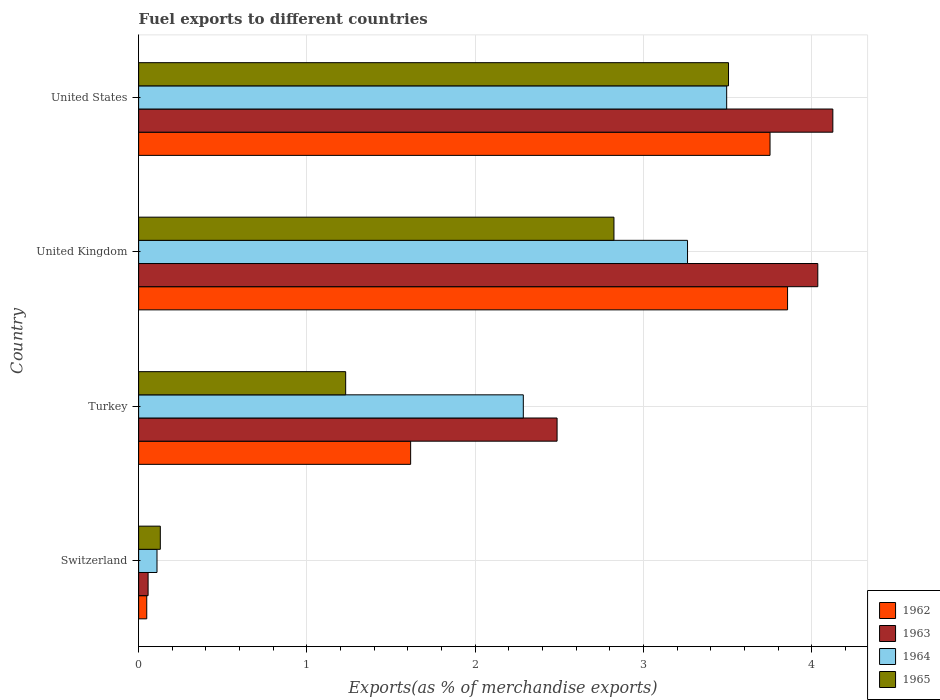How many groups of bars are there?
Your answer should be very brief. 4. What is the label of the 4th group of bars from the top?
Give a very brief answer. Switzerland. In how many cases, is the number of bars for a given country not equal to the number of legend labels?
Provide a short and direct response. 0. What is the percentage of exports to different countries in 1965 in Turkey?
Your answer should be compact. 1.23. Across all countries, what is the maximum percentage of exports to different countries in 1964?
Your answer should be very brief. 3.49. Across all countries, what is the minimum percentage of exports to different countries in 1963?
Your answer should be very brief. 0.06. In which country was the percentage of exports to different countries in 1964 maximum?
Make the answer very short. United States. In which country was the percentage of exports to different countries in 1963 minimum?
Your answer should be compact. Switzerland. What is the total percentage of exports to different countries in 1964 in the graph?
Provide a short and direct response. 9.15. What is the difference between the percentage of exports to different countries in 1962 in Switzerland and that in United States?
Provide a short and direct response. -3.7. What is the difference between the percentage of exports to different countries in 1962 in Switzerland and the percentage of exports to different countries in 1963 in Turkey?
Offer a terse response. -2.44. What is the average percentage of exports to different countries in 1965 per country?
Make the answer very short. 1.92. What is the difference between the percentage of exports to different countries in 1963 and percentage of exports to different countries in 1965 in United States?
Give a very brief answer. 0.62. What is the ratio of the percentage of exports to different countries in 1963 in United Kingdom to that in United States?
Give a very brief answer. 0.98. What is the difference between the highest and the second highest percentage of exports to different countries in 1964?
Provide a succinct answer. 0.23. What is the difference between the highest and the lowest percentage of exports to different countries in 1963?
Offer a very short reply. 4.07. In how many countries, is the percentage of exports to different countries in 1964 greater than the average percentage of exports to different countries in 1964 taken over all countries?
Ensure brevity in your answer.  2. What does the 3rd bar from the bottom in United Kingdom represents?
Ensure brevity in your answer.  1964. Is it the case that in every country, the sum of the percentage of exports to different countries in 1962 and percentage of exports to different countries in 1964 is greater than the percentage of exports to different countries in 1963?
Your response must be concise. Yes. Are all the bars in the graph horizontal?
Keep it short and to the point. Yes. How many countries are there in the graph?
Your answer should be compact. 4. What is the difference between two consecutive major ticks on the X-axis?
Offer a very short reply. 1. Are the values on the major ticks of X-axis written in scientific E-notation?
Give a very brief answer. No. Does the graph contain grids?
Keep it short and to the point. Yes. What is the title of the graph?
Provide a succinct answer. Fuel exports to different countries. Does "2010" appear as one of the legend labels in the graph?
Keep it short and to the point. No. What is the label or title of the X-axis?
Offer a terse response. Exports(as % of merchandise exports). What is the label or title of the Y-axis?
Your response must be concise. Country. What is the Exports(as % of merchandise exports) of 1962 in Switzerland?
Offer a very short reply. 0.05. What is the Exports(as % of merchandise exports) in 1963 in Switzerland?
Ensure brevity in your answer.  0.06. What is the Exports(as % of merchandise exports) of 1964 in Switzerland?
Offer a very short reply. 0.11. What is the Exports(as % of merchandise exports) of 1965 in Switzerland?
Your response must be concise. 0.13. What is the Exports(as % of merchandise exports) in 1962 in Turkey?
Give a very brief answer. 1.62. What is the Exports(as % of merchandise exports) of 1963 in Turkey?
Give a very brief answer. 2.49. What is the Exports(as % of merchandise exports) in 1964 in Turkey?
Ensure brevity in your answer.  2.29. What is the Exports(as % of merchandise exports) of 1965 in Turkey?
Give a very brief answer. 1.23. What is the Exports(as % of merchandise exports) of 1962 in United Kingdom?
Offer a terse response. 3.86. What is the Exports(as % of merchandise exports) in 1963 in United Kingdom?
Offer a terse response. 4.04. What is the Exports(as % of merchandise exports) of 1964 in United Kingdom?
Provide a succinct answer. 3.26. What is the Exports(as % of merchandise exports) in 1965 in United Kingdom?
Your answer should be compact. 2.82. What is the Exports(as % of merchandise exports) of 1962 in United States?
Make the answer very short. 3.75. What is the Exports(as % of merchandise exports) of 1963 in United States?
Provide a succinct answer. 4.13. What is the Exports(as % of merchandise exports) in 1964 in United States?
Provide a succinct answer. 3.49. What is the Exports(as % of merchandise exports) of 1965 in United States?
Offer a very short reply. 3.51. Across all countries, what is the maximum Exports(as % of merchandise exports) in 1962?
Your answer should be very brief. 3.86. Across all countries, what is the maximum Exports(as % of merchandise exports) in 1963?
Ensure brevity in your answer.  4.13. Across all countries, what is the maximum Exports(as % of merchandise exports) in 1964?
Provide a succinct answer. 3.49. Across all countries, what is the maximum Exports(as % of merchandise exports) of 1965?
Your answer should be compact. 3.51. Across all countries, what is the minimum Exports(as % of merchandise exports) of 1962?
Offer a very short reply. 0.05. Across all countries, what is the minimum Exports(as % of merchandise exports) of 1963?
Make the answer very short. 0.06. Across all countries, what is the minimum Exports(as % of merchandise exports) of 1964?
Your response must be concise. 0.11. Across all countries, what is the minimum Exports(as % of merchandise exports) of 1965?
Offer a very short reply. 0.13. What is the total Exports(as % of merchandise exports) in 1962 in the graph?
Offer a very short reply. 9.27. What is the total Exports(as % of merchandise exports) in 1963 in the graph?
Give a very brief answer. 10.7. What is the total Exports(as % of merchandise exports) of 1964 in the graph?
Provide a succinct answer. 9.15. What is the total Exports(as % of merchandise exports) of 1965 in the graph?
Provide a short and direct response. 7.69. What is the difference between the Exports(as % of merchandise exports) of 1962 in Switzerland and that in Turkey?
Your answer should be very brief. -1.57. What is the difference between the Exports(as % of merchandise exports) in 1963 in Switzerland and that in Turkey?
Your answer should be very brief. -2.43. What is the difference between the Exports(as % of merchandise exports) in 1964 in Switzerland and that in Turkey?
Keep it short and to the point. -2.18. What is the difference between the Exports(as % of merchandise exports) in 1965 in Switzerland and that in Turkey?
Give a very brief answer. -1.1. What is the difference between the Exports(as % of merchandise exports) of 1962 in Switzerland and that in United Kingdom?
Your answer should be compact. -3.81. What is the difference between the Exports(as % of merchandise exports) in 1963 in Switzerland and that in United Kingdom?
Your response must be concise. -3.98. What is the difference between the Exports(as % of merchandise exports) in 1964 in Switzerland and that in United Kingdom?
Make the answer very short. -3.15. What is the difference between the Exports(as % of merchandise exports) of 1965 in Switzerland and that in United Kingdom?
Offer a very short reply. -2.7. What is the difference between the Exports(as % of merchandise exports) of 1962 in Switzerland and that in United States?
Provide a succinct answer. -3.7. What is the difference between the Exports(as % of merchandise exports) in 1963 in Switzerland and that in United States?
Offer a very short reply. -4.07. What is the difference between the Exports(as % of merchandise exports) of 1964 in Switzerland and that in United States?
Provide a succinct answer. -3.39. What is the difference between the Exports(as % of merchandise exports) of 1965 in Switzerland and that in United States?
Make the answer very short. -3.38. What is the difference between the Exports(as % of merchandise exports) of 1962 in Turkey and that in United Kingdom?
Make the answer very short. -2.24. What is the difference between the Exports(as % of merchandise exports) of 1963 in Turkey and that in United Kingdom?
Provide a short and direct response. -1.55. What is the difference between the Exports(as % of merchandise exports) of 1964 in Turkey and that in United Kingdom?
Offer a terse response. -0.98. What is the difference between the Exports(as % of merchandise exports) of 1965 in Turkey and that in United Kingdom?
Offer a terse response. -1.59. What is the difference between the Exports(as % of merchandise exports) in 1962 in Turkey and that in United States?
Offer a terse response. -2.14. What is the difference between the Exports(as % of merchandise exports) of 1963 in Turkey and that in United States?
Your response must be concise. -1.64. What is the difference between the Exports(as % of merchandise exports) of 1964 in Turkey and that in United States?
Offer a very short reply. -1.21. What is the difference between the Exports(as % of merchandise exports) of 1965 in Turkey and that in United States?
Keep it short and to the point. -2.27. What is the difference between the Exports(as % of merchandise exports) in 1962 in United Kingdom and that in United States?
Your answer should be very brief. 0.1. What is the difference between the Exports(as % of merchandise exports) of 1963 in United Kingdom and that in United States?
Make the answer very short. -0.09. What is the difference between the Exports(as % of merchandise exports) in 1964 in United Kingdom and that in United States?
Make the answer very short. -0.23. What is the difference between the Exports(as % of merchandise exports) of 1965 in United Kingdom and that in United States?
Ensure brevity in your answer.  -0.68. What is the difference between the Exports(as % of merchandise exports) of 1962 in Switzerland and the Exports(as % of merchandise exports) of 1963 in Turkey?
Your answer should be very brief. -2.44. What is the difference between the Exports(as % of merchandise exports) of 1962 in Switzerland and the Exports(as % of merchandise exports) of 1964 in Turkey?
Your response must be concise. -2.24. What is the difference between the Exports(as % of merchandise exports) of 1962 in Switzerland and the Exports(as % of merchandise exports) of 1965 in Turkey?
Give a very brief answer. -1.18. What is the difference between the Exports(as % of merchandise exports) of 1963 in Switzerland and the Exports(as % of merchandise exports) of 1964 in Turkey?
Offer a terse response. -2.23. What is the difference between the Exports(as % of merchandise exports) of 1963 in Switzerland and the Exports(as % of merchandise exports) of 1965 in Turkey?
Provide a succinct answer. -1.17. What is the difference between the Exports(as % of merchandise exports) in 1964 in Switzerland and the Exports(as % of merchandise exports) in 1965 in Turkey?
Ensure brevity in your answer.  -1.12. What is the difference between the Exports(as % of merchandise exports) in 1962 in Switzerland and the Exports(as % of merchandise exports) in 1963 in United Kingdom?
Your response must be concise. -3.99. What is the difference between the Exports(as % of merchandise exports) of 1962 in Switzerland and the Exports(as % of merchandise exports) of 1964 in United Kingdom?
Make the answer very short. -3.21. What is the difference between the Exports(as % of merchandise exports) in 1962 in Switzerland and the Exports(as % of merchandise exports) in 1965 in United Kingdom?
Offer a very short reply. -2.78. What is the difference between the Exports(as % of merchandise exports) of 1963 in Switzerland and the Exports(as % of merchandise exports) of 1964 in United Kingdom?
Offer a very short reply. -3.21. What is the difference between the Exports(as % of merchandise exports) of 1963 in Switzerland and the Exports(as % of merchandise exports) of 1965 in United Kingdom?
Provide a succinct answer. -2.77. What is the difference between the Exports(as % of merchandise exports) of 1964 in Switzerland and the Exports(as % of merchandise exports) of 1965 in United Kingdom?
Provide a succinct answer. -2.72. What is the difference between the Exports(as % of merchandise exports) of 1962 in Switzerland and the Exports(as % of merchandise exports) of 1963 in United States?
Provide a succinct answer. -4.08. What is the difference between the Exports(as % of merchandise exports) of 1962 in Switzerland and the Exports(as % of merchandise exports) of 1964 in United States?
Offer a very short reply. -3.45. What is the difference between the Exports(as % of merchandise exports) of 1962 in Switzerland and the Exports(as % of merchandise exports) of 1965 in United States?
Make the answer very short. -3.46. What is the difference between the Exports(as % of merchandise exports) of 1963 in Switzerland and the Exports(as % of merchandise exports) of 1964 in United States?
Provide a succinct answer. -3.44. What is the difference between the Exports(as % of merchandise exports) in 1963 in Switzerland and the Exports(as % of merchandise exports) in 1965 in United States?
Provide a short and direct response. -3.45. What is the difference between the Exports(as % of merchandise exports) of 1964 in Switzerland and the Exports(as % of merchandise exports) of 1965 in United States?
Your answer should be very brief. -3.4. What is the difference between the Exports(as % of merchandise exports) of 1962 in Turkey and the Exports(as % of merchandise exports) of 1963 in United Kingdom?
Ensure brevity in your answer.  -2.42. What is the difference between the Exports(as % of merchandise exports) in 1962 in Turkey and the Exports(as % of merchandise exports) in 1964 in United Kingdom?
Make the answer very short. -1.65. What is the difference between the Exports(as % of merchandise exports) in 1962 in Turkey and the Exports(as % of merchandise exports) in 1965 in United Kingdom?
Ensure brevity in your answer.  -1.21. What is the difference between the Exports(as % of merchandise exports) in 1963 in Turkey and the Exports(as % of merchandise exports) in 1964 in United Kingdom?
Ensure brevity in your answer.  -0.78. What is the difference between the Exports(as % of merchandise exports) in 1963 in Turkey and the Exports(as % of merchandise exports) in 1965 in United Kingdom?
Keep it short and to the point. -0.34. What is the difference between the Exports(as % of merchandise exports) of 1964 in Turkey and the Exports(as % of merchandise exports) of 1965 in United Kingdom?
Offer a very short reply. -0.54. What is the difference between the Exports(as % of merchandise exports) in 1962 in Turkey and the Exports(as % of merchandise exports) in 1963 in United States?
Keep it short and to the point. -2.51. What is the difference between the Exports(as % of merchandise exports) in 1962 in Turkey and the Exports(as % of merchandise exports) in 1964 in United States?
Provide a short and direct response. -1.88. What is the difference between the Exports(as % of merchandise exports) in 1962 in Turkey and the Exports(as % of merchandise exports) in 1965 in United States?
Make the answer very short. -1.89. What is the difference between the Exports(as % of merchandise exports) in 1963 in Turkey and the Exports(as % of merchandise exports) in 1964 in United States?
Your response must be concise. -1.01. What is the difference between the Exports(as % of merchandise exports) of 1963 in Turkey and the Exports(as % of merchandise exports) of 1965 in United States?
Offer a terse response. -1.02. What is the difference between the Exports(as % of merchandise exports) of 1964 in Turkey and the Exports(as % of merchandise exports) of 1965 in United States?
Provide a short and direct response. -1.22. What is the difference between the Exports(as % of merchandise exports) in 1962 in United Kingdom and the Exports(as % of merchandise exports) in 1963 in United States?
Offer a terse response. -0.27. What is the difference between the Exports(as % of merchandise exports) of 1962 in United Kingdom and the Exports(as % of merchandise exports) of 1964 in United States?
Give a very brief answer. 0.36. What is the difference between the Exports(as % of merchandise exports) of 1962 in United Kingdom and the Exports(as % of merchandise exports) of 1965 in United States?
Give a very brief answer. 0.35. What is the difference between the Exports(as % of merchandise exports) in 1963 in United Kingdom and the Exports(as % of merchandise exports) in 1964 in United States?
Provide a short and direct response. 0.54. What is the difference between the Exports(as % of merchandise exports) in 1963 in United Kingdom and the Exports(as % of merchandise exports) in 1965 in United States?
Ensure brevity in your answer.  0.53. What is the difference between the Exports(as % of merchandise exports) of 1964 in United Kingdom and the Exports(as % of merchandise exports) of 1965 in United States?
Keep it short and to the point. -0.24. What is the average Exports(as % of merchandise exports) in 1962 per country?
Your answer should be compact. 2.32. What is the average Exports(as % of merchandise exports) in 1963 per country?
Provide a succinct answer. 2.68. What is the average Exports(as % of merchandise exports) of 1964 per country?
Keep it short and to the point. 2.29. What is the average Exports(as % of merchandise exports) of 1965 per country?
Give a very brief answer. 1.92. What is the difference between the Exports(as % of merchandise exports) in 1962 and Exports(as % of merchandise exports) in 1963 in Switzerland?
Keep it short and to the point. -0.01. What is the difference between the Exports(as % of merchandise exports) of 1962 and Exports(as % of merchandise exports) of 1964 in Switzerland?
Keep it short and to the point. -0.06. What is the difference between the Exports(as % of merchandise exports) in 1962 and Exports(as % of merchandise exports) in 1965 in Switzerland?
Ensure brevity in your answer.  -0.08. What is the difference between the Exports(as % of merchandise exports) in 1963 and Exports(as % of merchandise exports) in 1964 in Switzerland?
Provide a succinct answer. -0.05. What is the difference between the Exports(as % of merchandise exports) of 1963 and Exports(as % of merchandise exports) of 1965 in Switzerland?
Make the answer very short. -0.07. What is the difference between the Exports(as % of merchandise exports) in 1964 and Exports(as % of merchandise exports) in 1965 in Switzerland?
Offer a very short reply. -0.02. What is the difference between the Exports(as % of merchandise exports) of 1962 and Exports(as % of merchandise exports) of 1963 in Turkey?
Provide a short and direct response. -0.87. What is the difference between the Exports(as % of merchandise exports) of 1962 and Exports(as % of merchandise exports) of 1964 in Turkey?
Make the answer very short. -0.67. What is the difference between the Exports(as % of merchandise exports) in 1962 and Exports(as % of merchandise exports) in 1965 in Turkey?
Ensure brevity in your answer.  0.39. What is the difference between the Exports(as % of merchandise exports) in 1963 and Exports(as % of merchandise exports) in 1964 in Turkey?
Make the answer very short. 0.2. What is the difference between the Exports(as % of merchandise exports) in 1963 and Exports(as % of merchandise exports) in 1965 in Turkey?
Give a very brief answer. 1.26. What is the difference between the Exports(as % of merchandise exports) in 1964 and Exports(as % of merchandise exports) in 1965 in Turkey?
Keep it short and to the point. 1.06. What is the difference between the Exports(as % of merchandise exports) in 1962 and Exports(as % of merchandise exports) in 1963 in United Kingdom?
Give a very brief answer. -0.18. What is the difference between the Exports(as % of merchandise exports) in 1962 and Exports(as % of merchandise exports) in 1964 in United Kingdom?
Keep it short and to the point. 0.59. What is the difference between the Exports(as % of merchandise exports) of 1962 and Exports(as % of merchandise exports) of 1965 in United Kingdom?
Your answer should be compact. 1.03. What is the difference between the Exports(as % of merchandise exports) of 1963 and Exports(as % of merchandise exports) of 1964 in United Kingdom?
Provide a short and direct response. 0.77. What is the difference between the Exports(as % of merchandise exports) in 1963 and Exports(as % of merchandise exports) in 1965 in United Kingdom?
Offer a very short reply. 1.21. What is the difference between the Exports(as % of merchandise exports) of 1964 and Exports(as % of merchandise exports) of 1965 in United Kingdom?
Provide a short and direct response. 0.44. What is the difference between the Exports(as % of merchandise exports) of 1962 and Exports(as % of merchandise exports) of 1963 in United States?
Make the answer very short. -0.37. What is the difference between the Exports(as % of merchandise exports) in 1962 and Exports(as % of merchandise exports) in 1964 in United States?
Provide a short and direct response. 0.26. What is the difference between the Exports(as % of merchandise exports) of 1962 and Exports(as % of merchandise exports) of 1965 in United States?
Give a very brief answer. 0.25. What is the difference between the Exports(as % of merchandise exports) in 1963 and Exports(as % of merchandise exports) in 1964 in United States?
Offer a very short reply. 0.63. What is the difference between the Exports(as % of merchandise exports) in 1963 and Exports(as % of merchandise exports) in 1965 in United States?
Your answer should be very brief. 0.62. What is the difference between the Exports(as % of merchandise exports) in 1964 and Exports(as % of merchandise exports) in 1965 in United States?
Make the answer very short. -0.01. What is the ratio of the Exports(as % of merchandise exports) of 1962 in Switzerland to that in Turkey?
Your response must be concise. 0.03. What is the ratio of the Exports(as % of merchandise exports) of 1963 in Switzerland to that in Turkey?
Your answer should be very brief. 0.02. What is the ratio of the Exports(as % of merchandise exports) of 1964 in Switzerland to that in Turkey?
Keep it short and to the point. 0.05. What is the ratio of the Exports(as % of merchandise exports) in 1965 in Switzerland to that in Turkey?
Give a very brief answer. 0.1. What is the ratio of the Exports(as % of merchandise exports) in 1962 in Switzerland to that in United Kingdom?
Ensure brevity in your answer.  0.01. What is the ratio of the Exports(as % of merchandise exports) of 1963 in Switzerland to that in United Kingdom?
Give a very brief answer. 0.01. What is the ratio of the Exports(as % of merchandise exports) in 1964 in Switzerland to that in United Kingdom?
Offer a terse response. 0.03. What is the ratio of the Exports(as % of merchandise exports) of 1965 in Switzerland to that in United Kingdom?
Give a very brief answer. 0.05. What is the ratio of the Exports(as % of merchandise exports) of 1962 in Switzerland to that in United States?
Provide a succinct answer. 0.01. What is the ratio of the Exports(as % of merchandise exports) in 1963 in Switzerland to that in United States?
Keep it short and to the point. 0.01. What is the ratio of the Exports(as % of merchandise exports) of 1964 in Switzerland to that in United States?
Ensure brevity in your answer.  0.03. What is the ratio of the Exports(as % of merchandise exports) of 1965 in Switzerland to that in United States?
Provide a short and direct response. 0.04. What is the ratio of the Exports(as % of merchandise exports) in 1962 in Turkey to that in United Kingdom?
Ensure brevity in your answer.  0.42. What is the ratio of the Exports(as % of merchandise exports) in 1963 in Turkey to that in United Kingdom?
Ensure brevity in your answer.  0.62. What is the ratio of the Exports(as % of merchandise exports) in 1964 in Turkey to that in United Kingdom?
Provide a succinct answer. 0.7. What is the ratio of the Exports(as % of merchandise exports) of 1965 in Turkey to that in United Kingdom?
Keep it short and to the point. 0.44. What is the ratio of the Exports(as % of merchandise exports) of 1962 in Turkey to that in United States?
Ensure brevity in your answer.  0.43. What is the ratio of the Exports(as % of merchandise exports) of 1963 in Turkey to that in United States?
Ensure brevity in your answer.  0.6. What is the ratio of the Exports(as % of merchandise exports) in 1964 in Turkey to that in United States?
Your answer should be compact. 0.65. What is the ratio of the Exports(as % of merchandise exports) in 1965 in Turkey to that in United States?
Give a very brief answer. 0.35. What is the ratio of the Exports(as % of merchandise exports) of 1962 in United Kingdom to that in United States?
Ensure brevity in your answer.  1.03. What is the ratio of the Exports(as % of merchandise exports) in 1963 in United Kingdom to that in United States?
Offer a very short reply. 0.98. What is the ratio of the Exports(as % of merchandise exports) in 1964 in United Kingdom to that in United States?
Give a very brief answer. 0.93. What is the ratio of the Exports(as % of merchandise exports) of 1965 in United Kingdom to that in United States?
Your answer should be compact. 0.81. What is the difference between the highest and the second highest Exports(as % of merchandise exports) in 1962?
Provide a succinct answer. 0.1. What is the difference between the highest and the second highest Exports(as % of merchandise exports) in 1963?
Your response must be concise. 0.09. What is the difference between the highest and the second highest Exports(as % of merchandise exports) of 1964?
Give a very brief answer. 0.23. What is the difference between the highest and the second highest Exports(as % of merchandise exports) of 1965?
Provide a short and direct response. 0.68. What is the difference between the highest and the lowest Exports(as % of merchandise exports) in 1962?
Offer a very short reply. 3.81. What is the difference between the highest and the lowest Exports(as % of merchandise exports) of 1963?
Ensure brevity in your answer.  4.07. What is the difference between the highest and the lowest Exports(as % of merchandise exports) in 1964?
Provide a succinct answer. 3.39. What is the difference between the highest and the lowest Exports(as % of merchandise exports) of 1965?
Offer a very short reply. 3.38. 